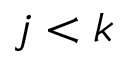<formula> <loc_0><loc_0><loc_500><loc_500>j < k</formula> 